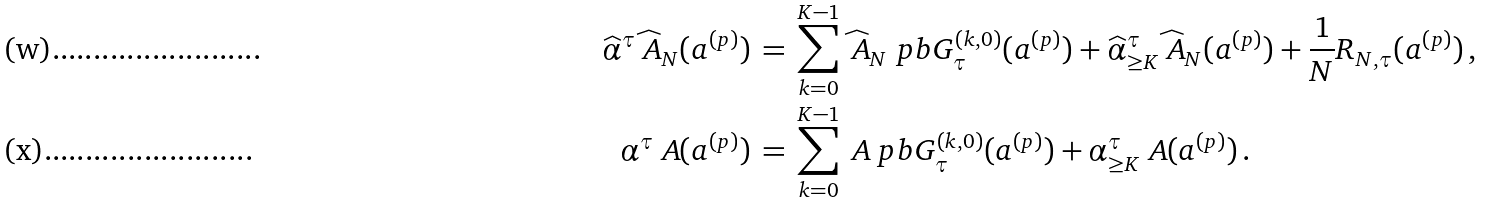Convert formula to latex. <formula><loc_0><loc_0><loc_500><loc_500>\widehat { \alpha } ^ { \tau } \widehat { \ A } _ { N } ( a ^ { ( p ) } ) & \, = \, \sum _ { k = 0 } ^ { K - 1 } \widehat { \ A } _ { N } \ p b { G _ { \tau } ^ { ( k , 0 ) } ( a ^ { ( p ) } ) } + \widehat { \alpha } ^ { \tau } _ { \geq K } \widehat { \ A } _ { N } ( a ^ { ( p ) } ) + \frac { 1 } { N } R _ { N , \tau } ( a ^ { ( p ) } ) \, , \\ \alpha ^ { \tau } \ A ( a ^ { ( p ) } ) & \, = \, \sum _ { k = 0 } ^ { K - 1 } \ A \ p b { G _ { \tau } ^ { ( k , 0 ) } ( a ^ { ( p ) } ) } + \alpha ^ { \tau } _ { \geq K } \ A ( a ^ { ( p ) } ) \, .</formula> 